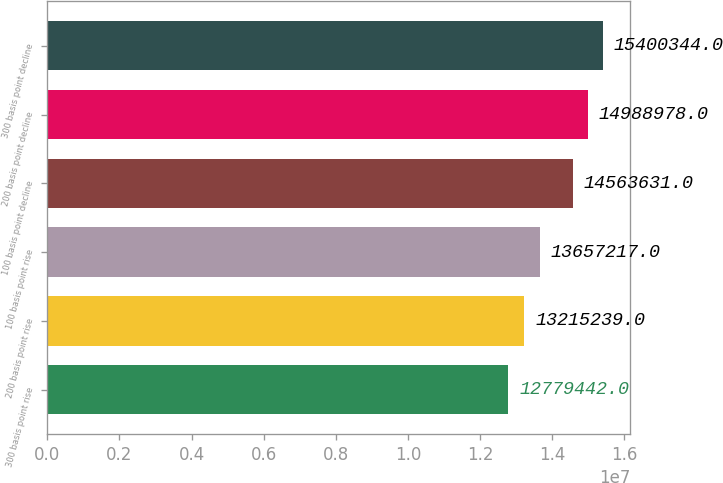Convert chart to OTSL. <chart><loc_0><loc_0><loc_500><loc_500><bar_chart><fcel>300 basis point rise<fcel>200 basis point rise<fcel>100 basis point rise<fcel>100 basis point decline<fcel>200 basis point decline<fcel>300 basis point decline<nl><fcel>1.27794e+07<fcel>1.32152e+07<fcel>1.36572e+07<fcel>1.45636e+07<fcel>1.4989e+07<fcel>1.54003e+07<nl></chart> 